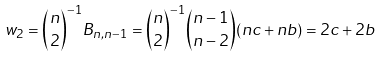<formula> <loc_0><loc_0><loc_500><loc_500>w _ { 2 } = { n \choose 2 } ^ { - 1 } B _ { n , n - 1 } = { n \choose 2 } ^ { - 1 } { n - 1 \choose n - 2 } ( n c + n b ) = 2 c + 2 b</formula> 